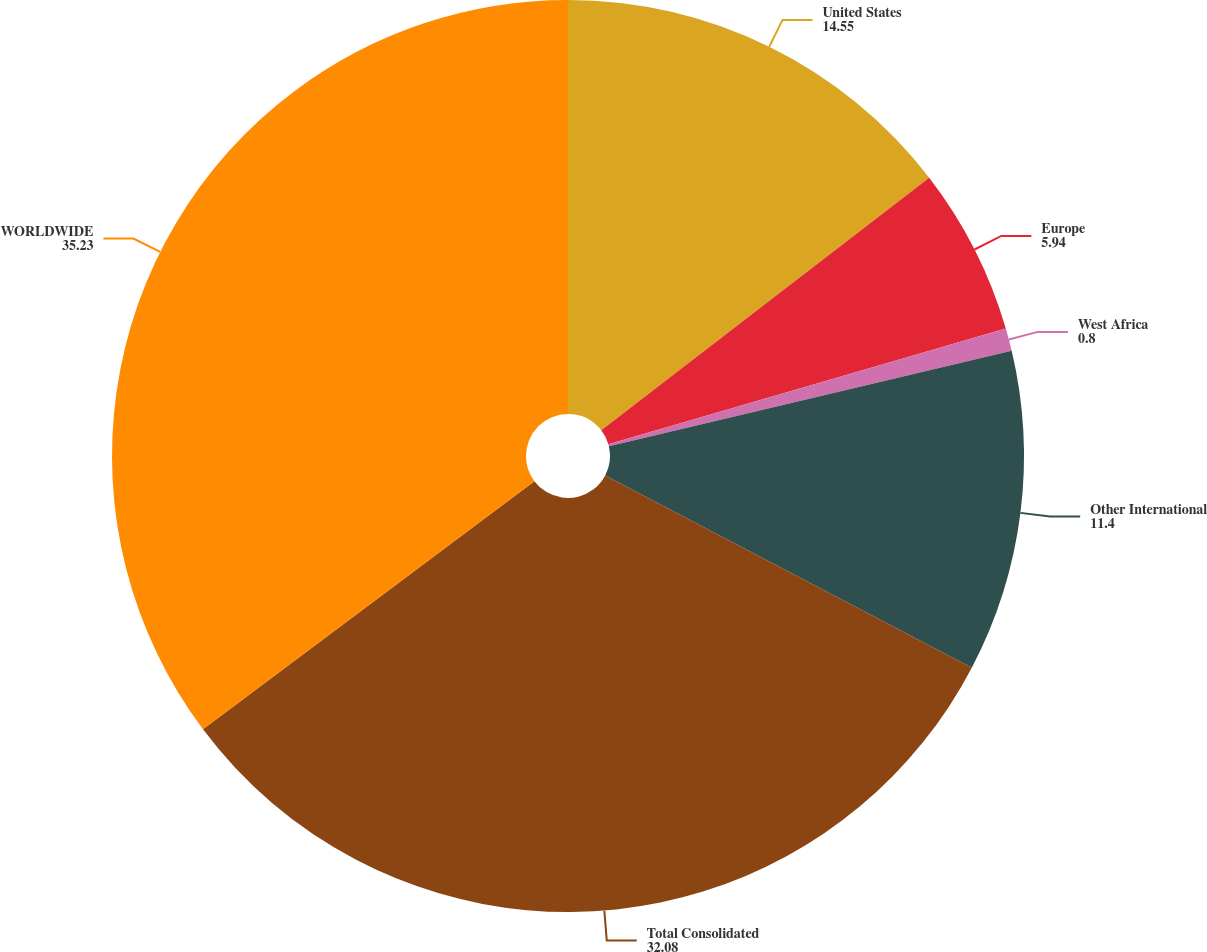Convert chart to OTSL. <chart><loc_0><loc_0><loc_500><loc_500><pie_chart><fcel>United States<fcel>Europe<fcel>West Africa<fcel>Other International<fcel>Total Consolidated<fcel>WORLDWIDE<nl><fcel>14.55%<fcel>5.94%<fcel>0.8%<fcel>11.4%<fcel>32.08%<fcel>35.23%<nl></chart> 